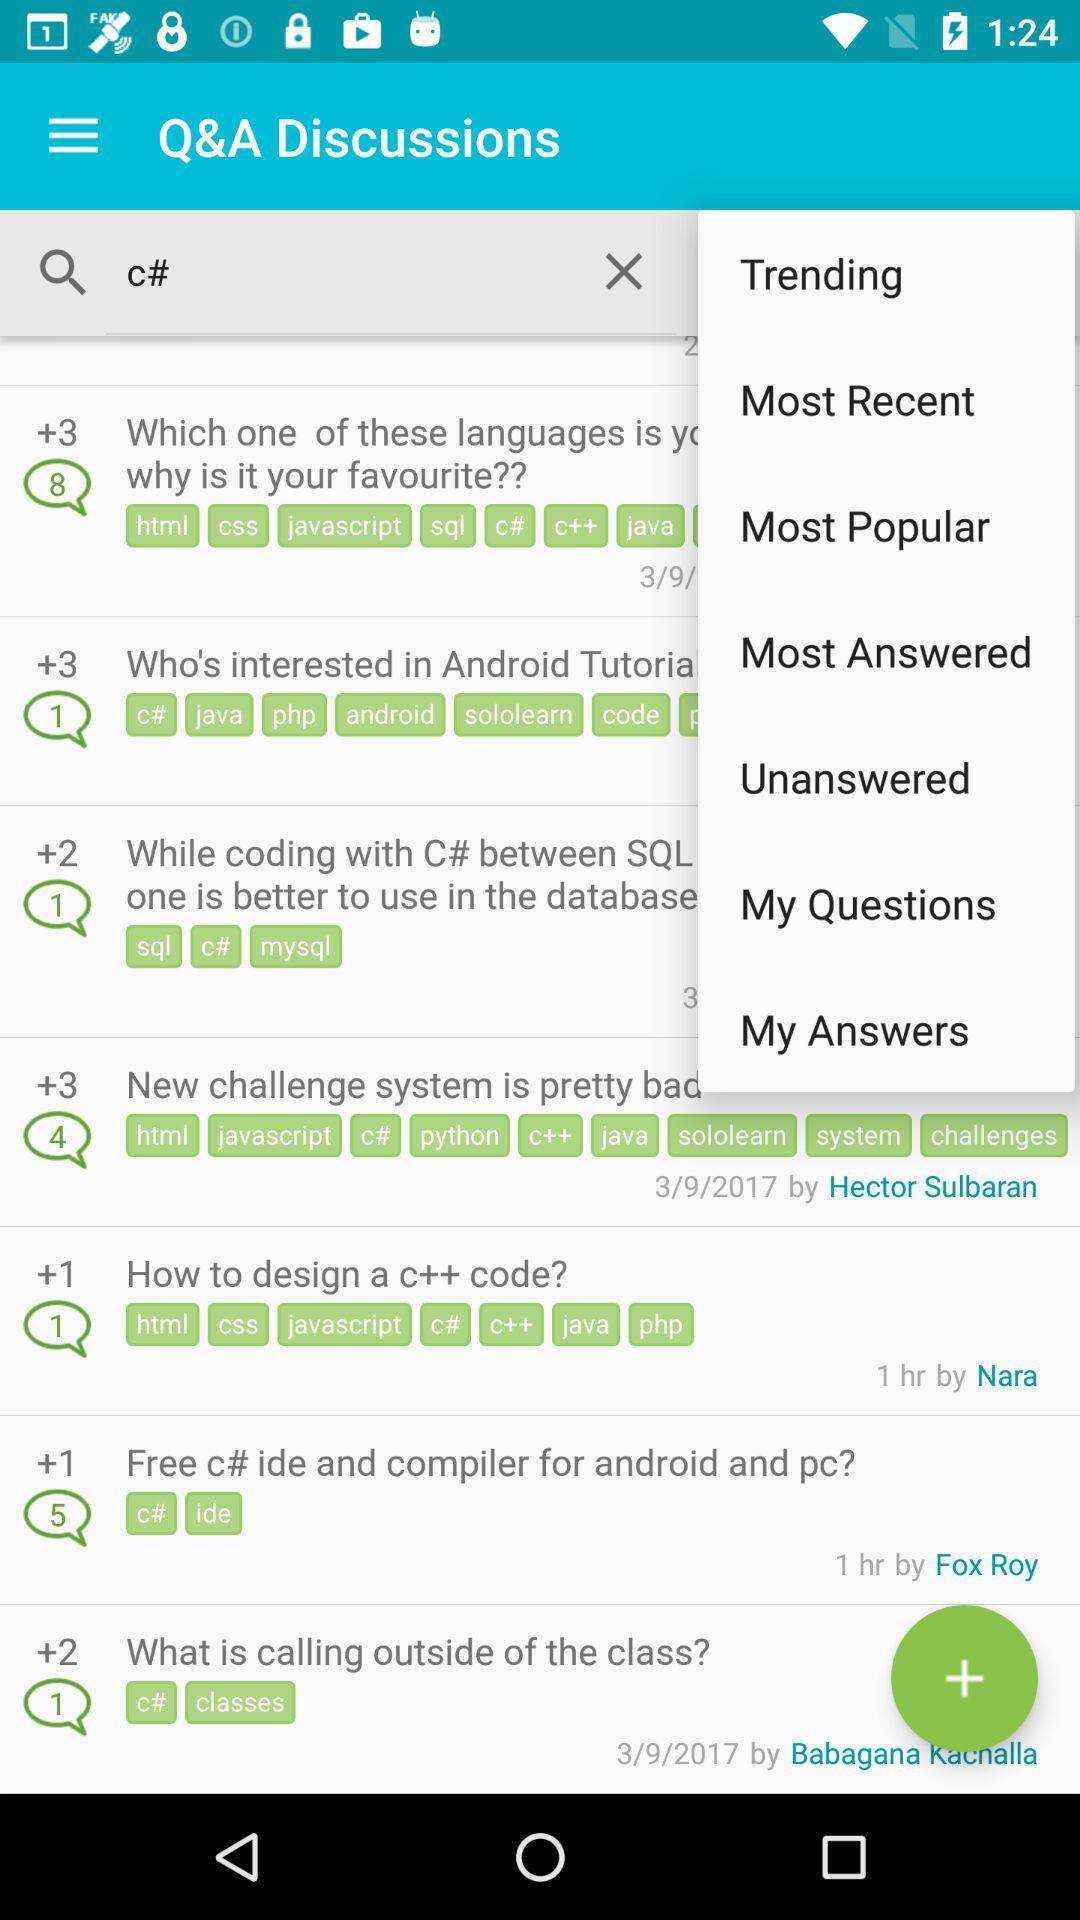How many points are received for answering right "How to design a c++ code?"? There are +1 points received for answering right "How to design a c++ code?". 